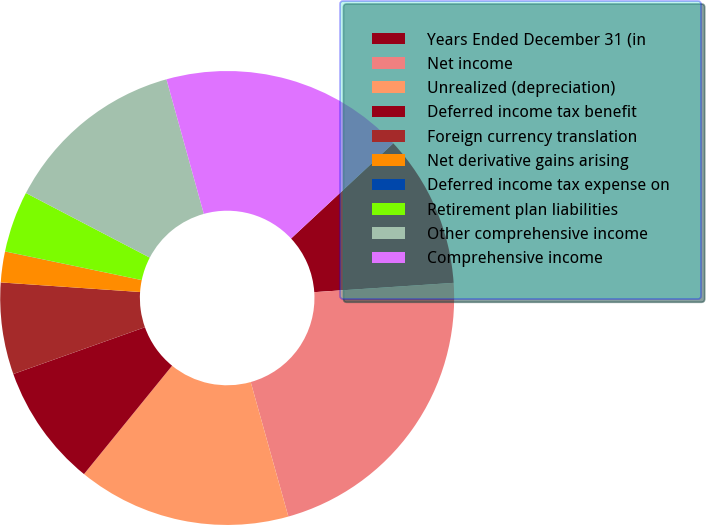<chart> <loc_0><loc_0><loc_500><loc_500><pie_chart><fcel>Years Ended December 31 (in<fcel>Net income<fcel>Unrealized (depreciation)<fcel>Deferred income tax benefit<fcel>Foreign currency translation<fcel>Net derivative gains arising<fcel>Deferred income tax expense on<fcel>Retirement plan liabilities<fcel>Other comprehensive income<fcel>Comprehensive income<nl><fcel>10.87%<fcel>21.72%<fcel>15.21%<fcel>8.7%<fcel>6.53%<fcel>2.19%<fcel>0.01%<fcel>4.36%<fcel>13.04%<fcel>17.38%<nl></chart> 